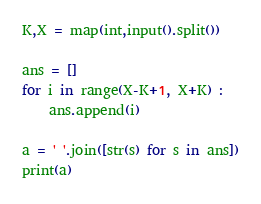<code> <loc_0><loc_0><loc_500><loc_500><_Python_>K,X = map(int,input().split())

ans = []
for i in range(X-K+1, X+K) :
    ans.append(i)

a = ' '.join([str(s) for s in ans])
print(a)</code> 